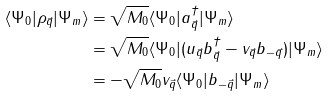Convert formula to latex. <formula><loc_0><loc_0><loc_500><loc_500>\langle \Psi _ { 0 } | \rho _ { \vec { q } } | \Psi _ { m } \rangle & = \sqrt { M _ { 0 } } \langle \Psi _ { 0 } | a _ { \vec { q } } ^ { \dagger } | \Psi _ { m } \rangle \\ & = \sqrt { M _ { 0 } } \langle \Psi _ { 0 } | ( u _ { \vec { q } } b _ { \vec { q } } ^ { \dagger } - v _ { \vec { q } } b _ { - { \vec { q } } } ) | \Psi _ { m } \rangle \\ & = - \sqrt { M _ { 0 } } v _ { \vec { q } } \langle \Psi _ { 0 } | b _ { - { \vec { q } } } | \Psi _ { m } \rangle</formula> 